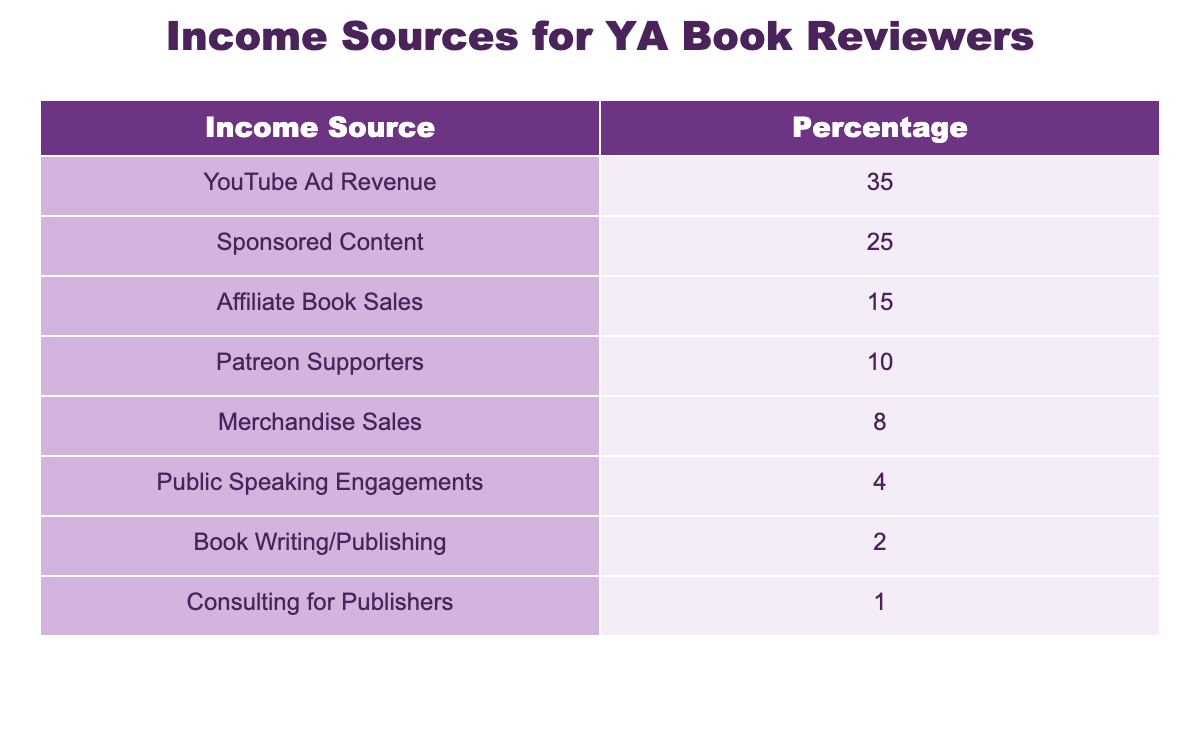What is the highest income source for YA book reviewers? From the table, the income sources listed with their percentages show that "YouTube Ad Revenue" has the highest percentage at 35%.
Answer: YouTube Ad Revenue What percentage of income comes from sponsored content? The table lists "Sponsored Content" with a percentage of 25%.
Answer: 25% How much more revenue is generated from YouTube Ad Revenue compared to Merchandise Sales? YouTube Ad Revenue is 35% and Merchandise Sales is 8%. The difference is 35% - 8% = 27%.
Answer: 27% Is the income from consulting for publishers greater than book writing/publishing? "Consulting for Publishers" has a percentage of 1% and "Book Writing/Publishing" has 2%. Since 1% is less than 2%, the statement is false.
Answer: No What cumulative percentage do the top three income sources represent? The top three income sources are YouTube Ad Revenue (35%), Sponsored Content (25%), and Affiliate Book Sales (15%). Their cumulative percentage is 35% + 25% + 15% = 75%.
Answer: 75% What is the total percentage of income sources that contribute less than 10%? The income sources contributing less than 10% are Merchandise Sales (8%), Public Speaking Engagements (4%), Book Writing/Publishing (2%), and Consulting for Publishers (1%). Adding them gives 8% + 4% + 2% + 1% = 15%.
Answer: 15% Is the revenue from Patreon Supporters equal to that from Merchandise Sales? "Patreon Supporters" makes up 10% while "Merchandise Sales" is 8%. Since 10% is greater than 8%, the two are not equal, making the statement false.
Answer: No What percentage of the total income sources do public speaking engagements and consulting together make? Public Speaking Engagements make up 4% and Consulting for Publishers 1%. Adding these gives 4% + 1% = 5%.
Answer: 5% 